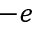Convert formula to latex. <formula><loc_0><loc_0><loc_500><loc_500>- e</formula> 